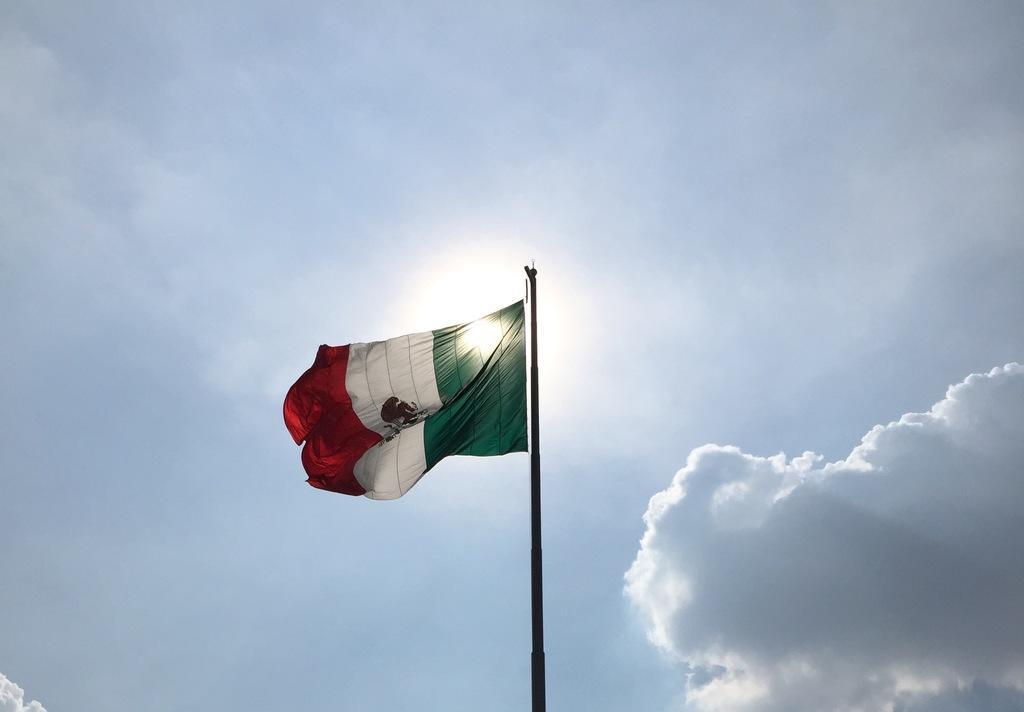Can you describe this image briefly? In this picture there is a flag on the pole. At the top there is sky and there are clouds and there is a sun and the flag is in orange, white, green and in black colour. 